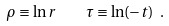<formula> <loc_0><loc_0><loc_500><loc_500>\rho \equiv \ln { r } \quad \tau \equiv \ln ( { - t } ) \ .</formula> 